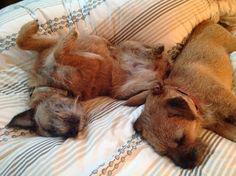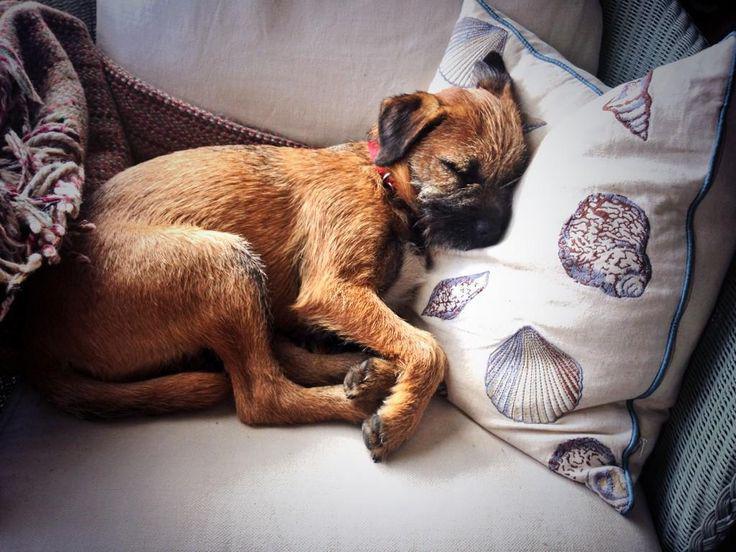The first image is the image on the left, the second image is the image on the right. For the images displayed, is the sentence "One image shows two dogs snoozing together." factually correct? Answer yes or no. Yes. The first image is the image on the left, the second image is the image on the right. Considering the images on both sides, is "There are three dogs sleeping" valid? Answer yes or no. Yes. 